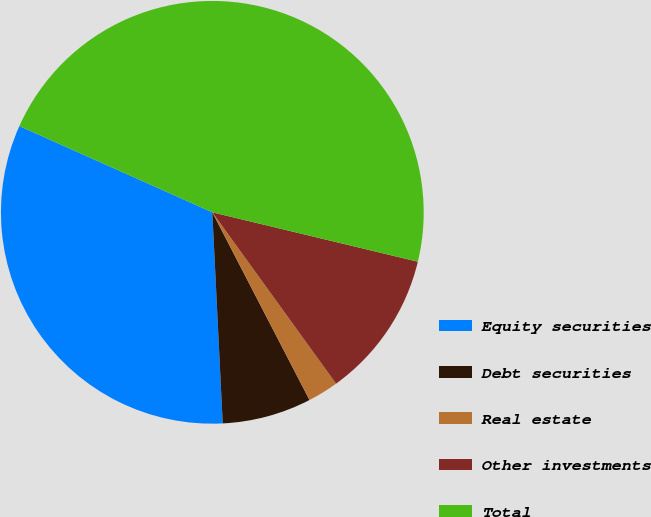Convert chart to OTSL. <chart><loc_0><loc_0><loc_500><loc_500><pie_chart><fcel>Equity securities<fcel>Debt securities<fcel>Real estate<fcel>Other investments<fcel>Total<nl><fcel>32.47%<fcel>6.82%<fcel>2.35%<fcel>11.29%<fcel>47.06%<nl></chart> 